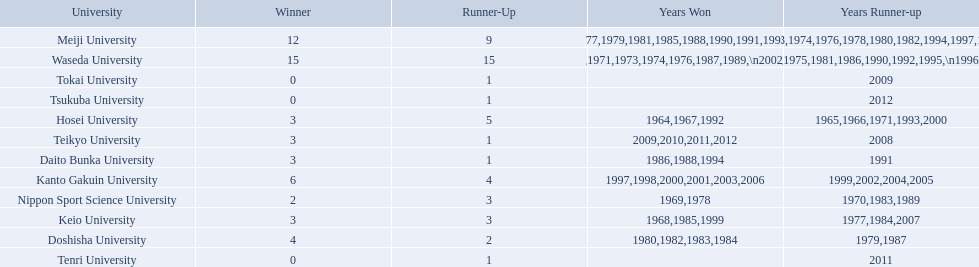What university were there in the all-japan university rugby championship? Waseda University, Meiji University, Kanto Gakuin University, Doshisha University, Hosei University, Keio University, Daito Bunka University, Nippon Sport Science University, Teikyo University, Tokai University, Tenri University, Tsukuba University. Of these who had more than 12 wins? Waseda University. 